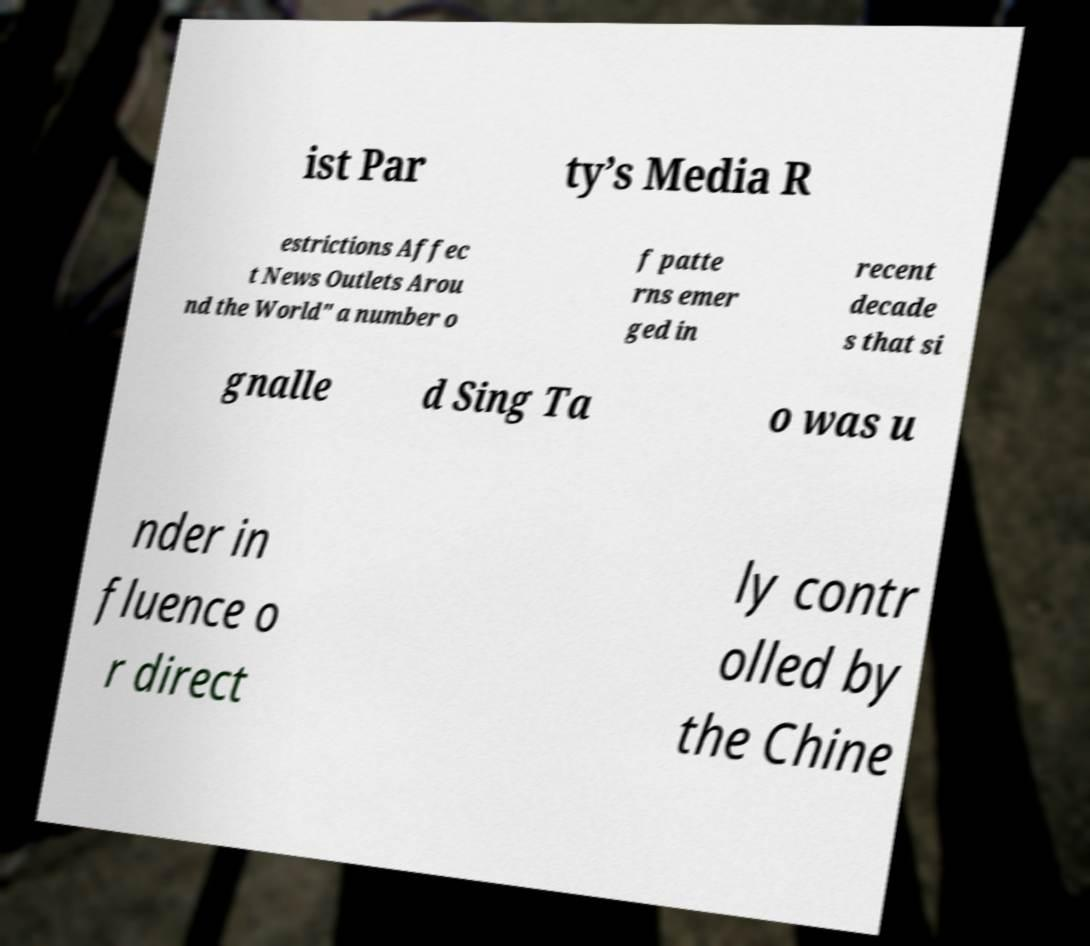Please identify and transcribe the text found in this image. ist Par ty’s Media R estrictions Affec t News Outlets Arou nd the World" a number o f patte rns emer ged in recent decade s that si gnalle d Sing Ta o was u nder in fluence o r direct ly contr olled by the Chine 